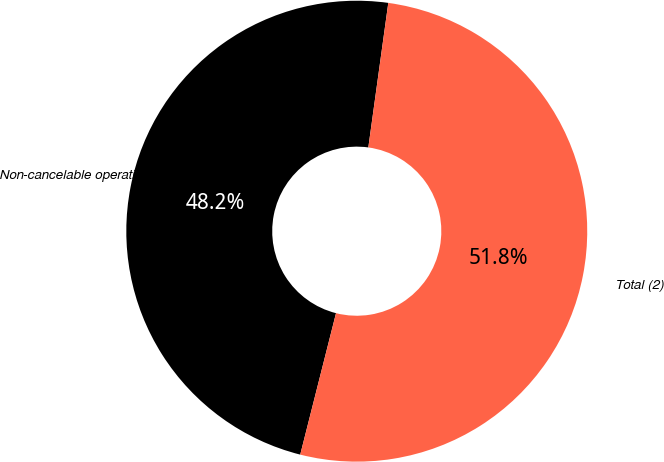<chart> <loc_0><loc_0><loc_500><loc_500><pie_chart><fcel>Non-cancelable operating<fcel>Total (2)<nl><fcel>48.24%<fcel>51.76%<nl></chart> 